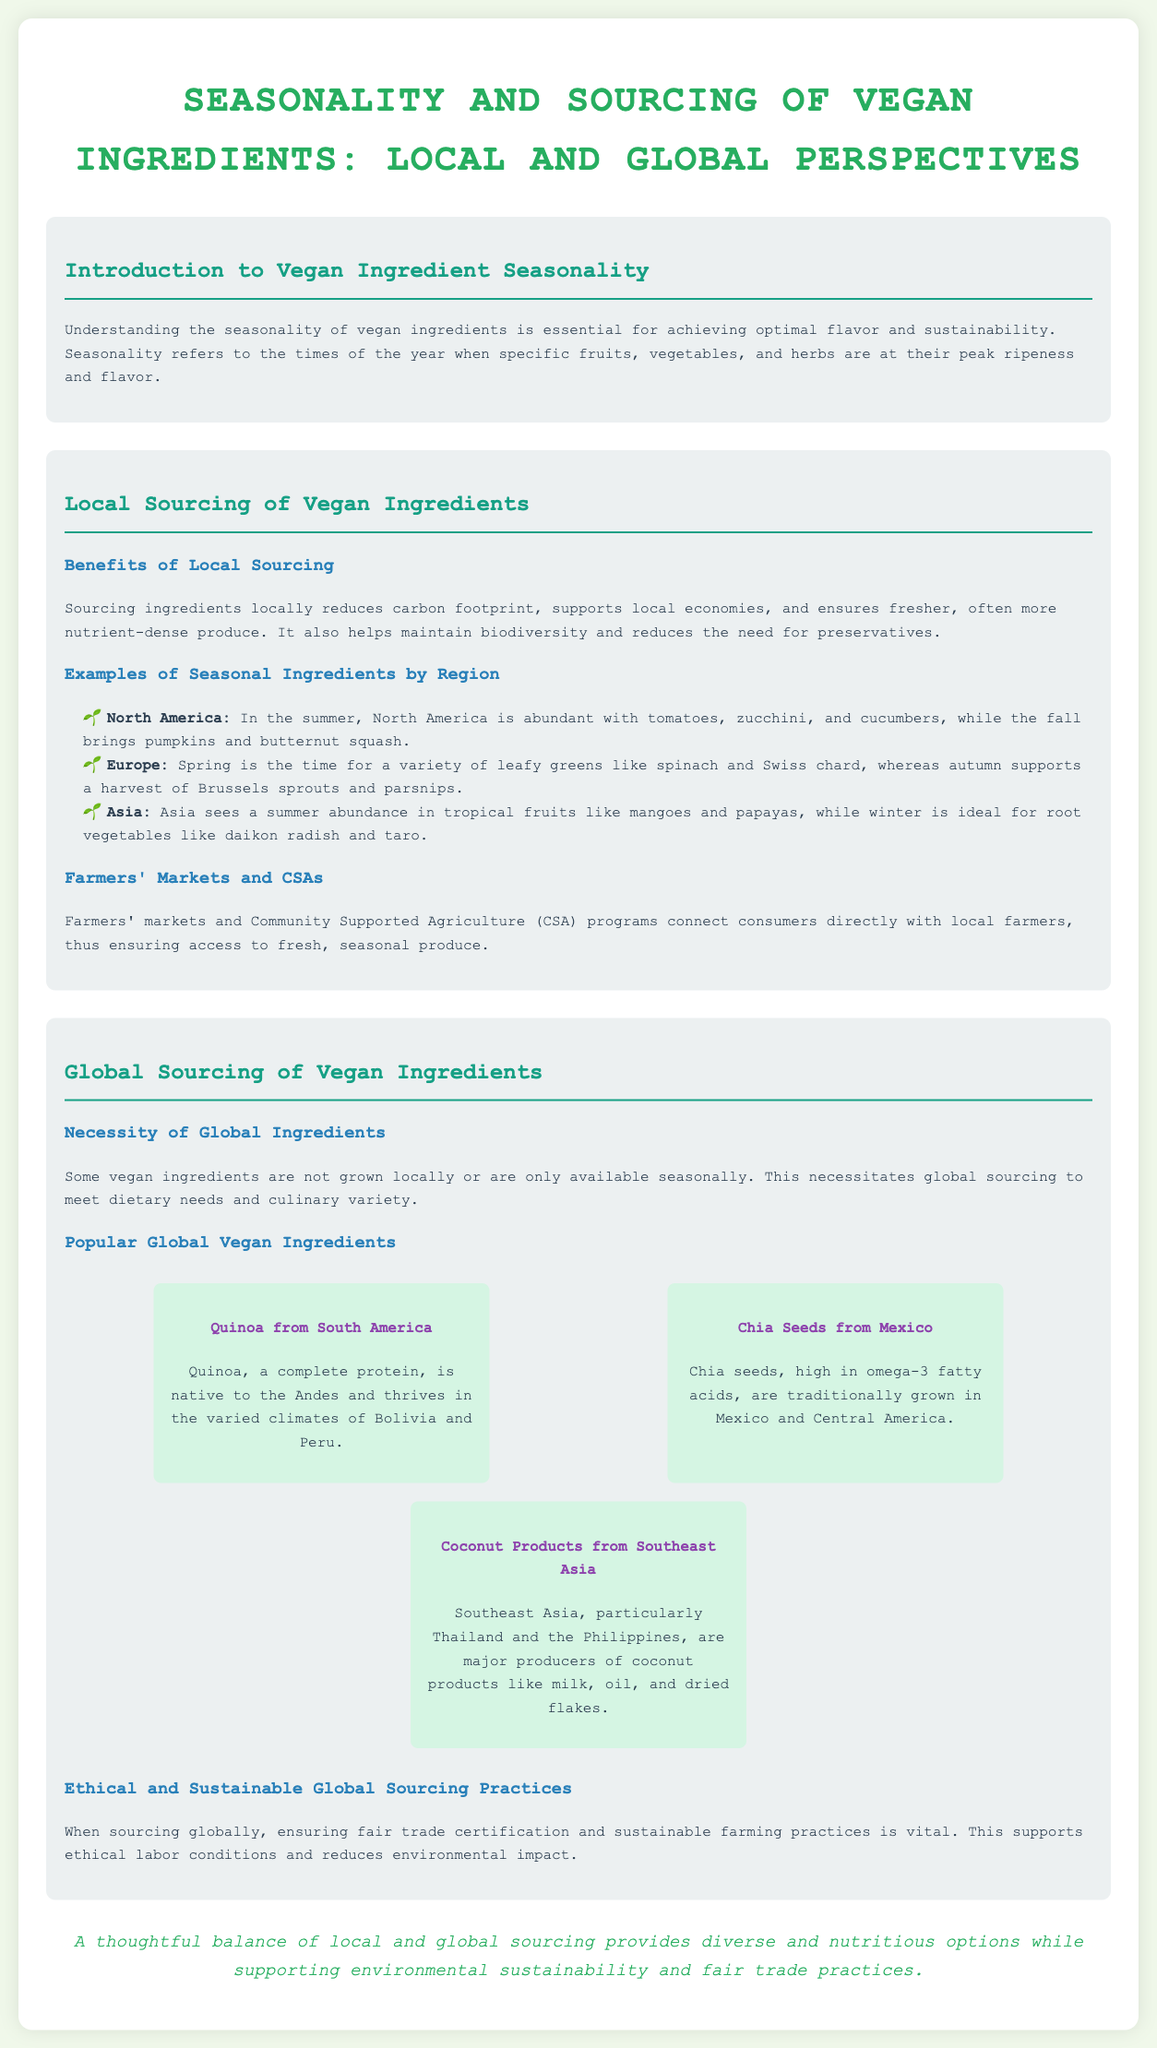What is the title of the document? The title is stated at the top of the document and is "Seasonality and Sourcing of Vegan Ingredients: Local and Global Perspectives."
Answer: Seasonality and Sourcing of Vegan Ingredients: Local and Global Perspectives What are the benefits of local sourcing mentioned? The document lists several benefits of local sourcing such as reducing carbon footprint, supporting local economies, ensuring fresher produce, maintaining biodiversity, and reducing the need for preservatives.
Answer: Reducing carbon footprint, supporting local economies, ensuring fresher produce, maintaining biodiversity, reducing need for preservatives Which region in North America has an abundance of tomatoes? The document specifies that in the summer, North America is abundant with tomatoes, along with zucchini and cucumbers.
Answer: North America What is a popular global vegan ingredient from South America? The document identifies quinoa as a popular global vegan ingredient from South America.
Answer: Quinoa What season is ideal for root vegetables in Asia? According to the document, winter is the ideal season for root vegetables like daikon radish and taro in Asia.
Answer: Winter What are the ethical practices mentioned for global sourcing? The document emphasizes the importance of fair trade certification and sustainable farming practices.
Answer: Fair trade certification and sustainable farming practices How does the document describe the balance between local and global sourcing? The conclusion summarizes that a thoughtful balance of local and global sourcing provides diverse and nutritious options while supporting environmental sustainability and fair trade practices.
Answer: Diverse and nutritious options while supporting environmental sustainability and fair trade practices What type of farming does the document recommend for global sourcing? The document recommends ensuring sustainable farming practices when sourcing globally.
Answer: Sustainable farming practices 